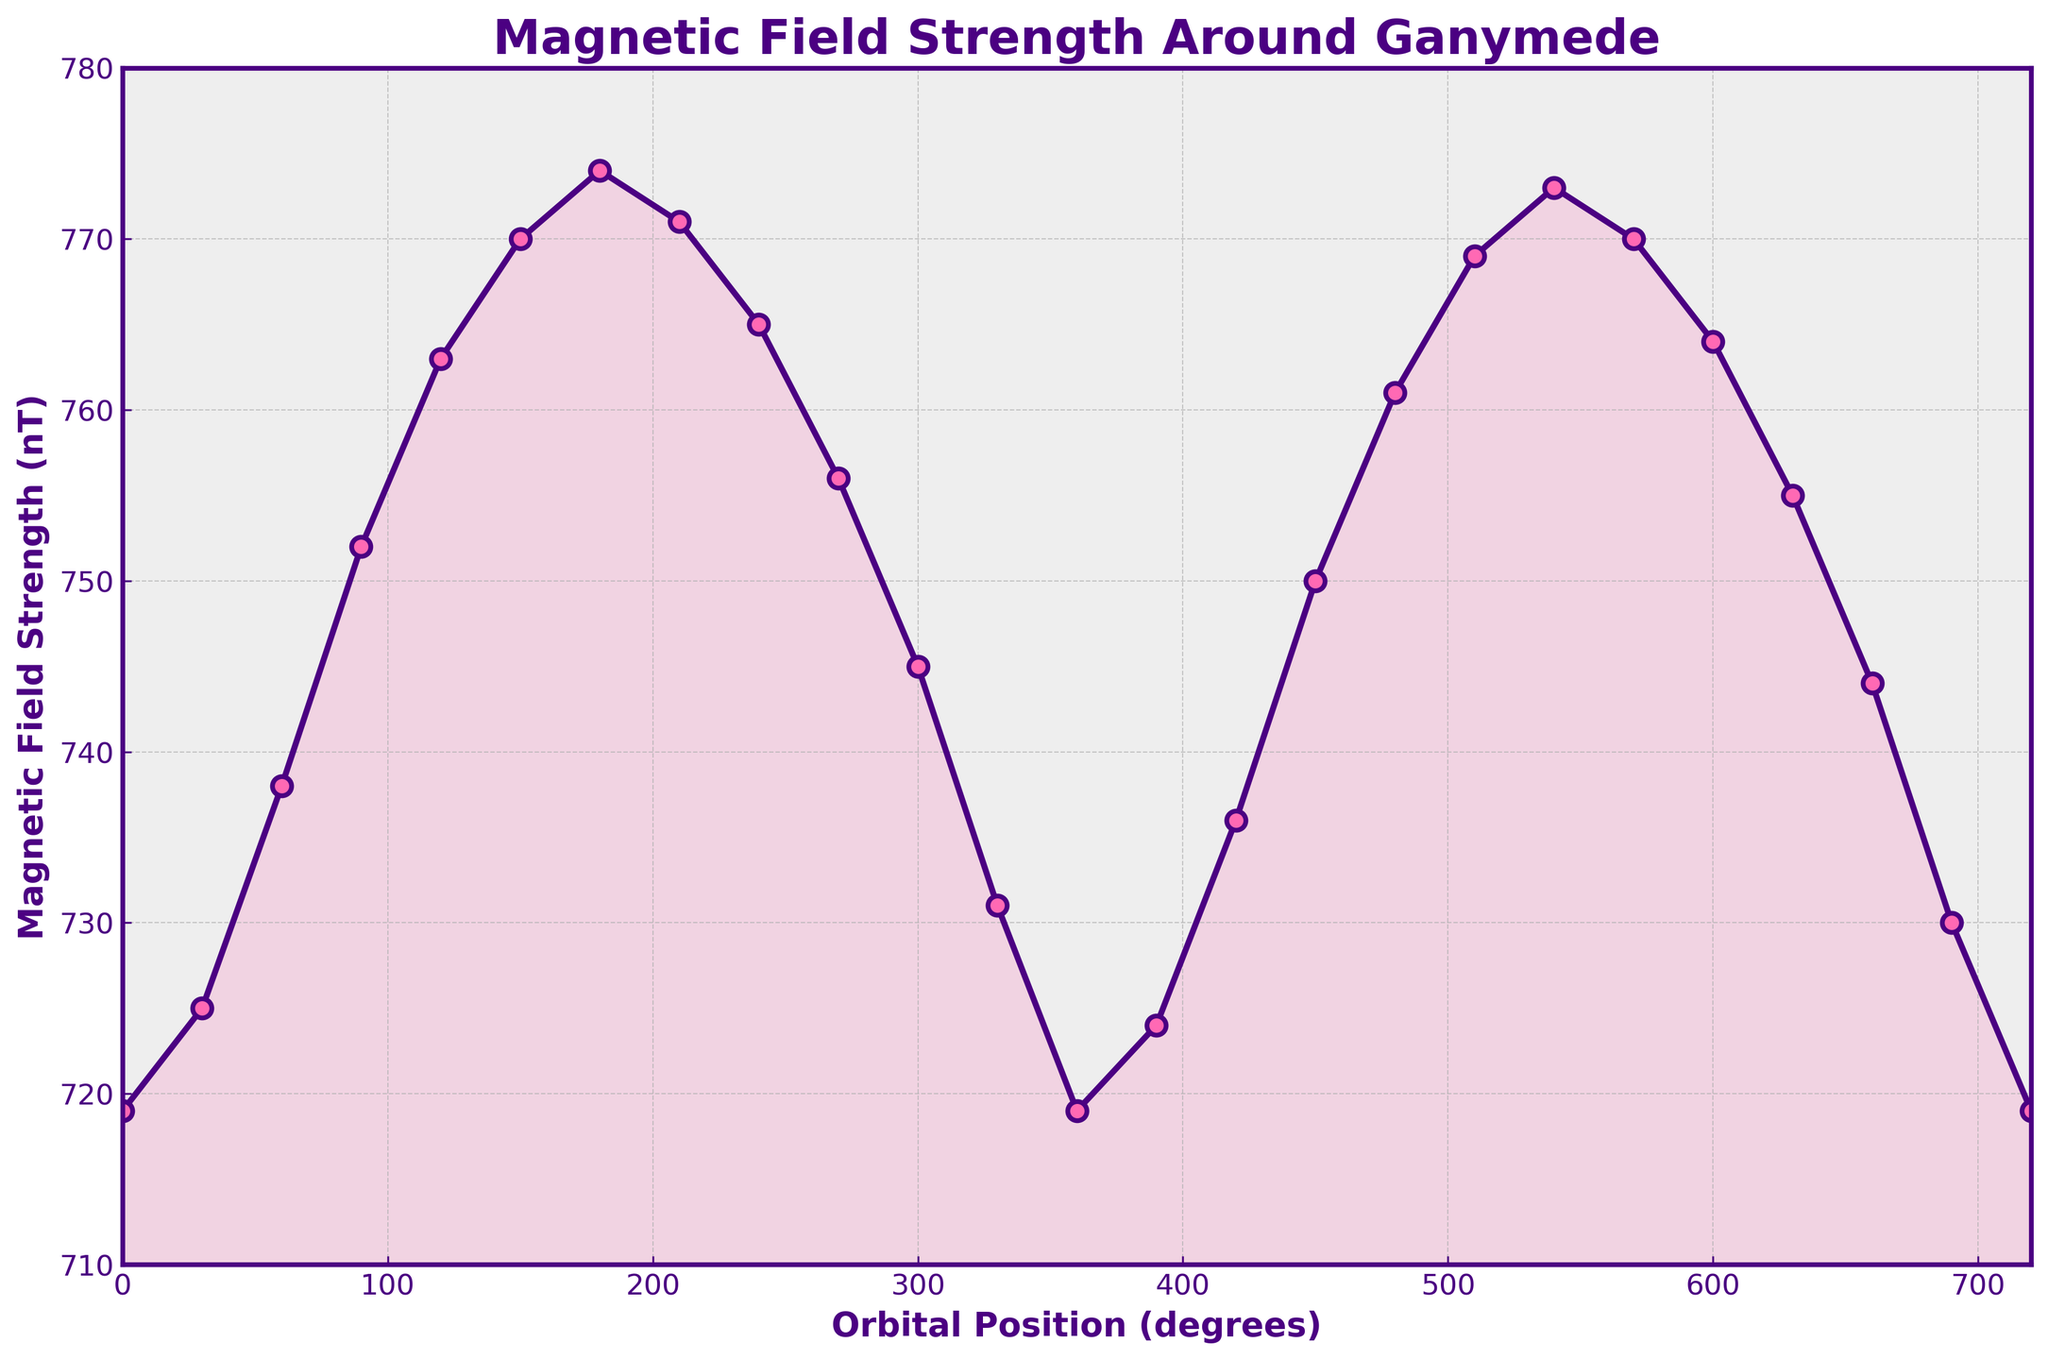How often does the magnetic field strength return to its initial value throughout the plotted orbital positions? The figure shows the magnetic field strength starting and ending at roughly 719 nT, which happens at orbital positions 0, 360, and 720 degrees, indicating it occurs approximately every 360 degrees.
Answer: Every 360 degrees What is the maximum magnetic field strength recorded, and at what orbital position does it occur? The highest point on the graph represents the peak value. According to the figure, the maximum magnetic field strength is 774 nT, which occurs at an orbital position of 180 degrees.
Answer: 774 nT at 180 degrees At which orbital positions is the magnetic field strength exactly 770 nT? By inspecting the graph, the value of 770 nT occurs at approximately 150 and 570 degrees, where the y-values hit the 770 nT mark.
Answer: 150 degrees and 570 degrees How much variation is observed in the magnetic field strength between the lowest and highest recorded values? The lowest value in the graph is approximately 719 nT, and the highest is approximately 774 nT. The variation can be calculated as 774 nT - 719 nT = 55 nT.
Answer: 55 nT What is the average magnetic field strength over one complete orbit (0 to 360 degrees)? To find the average, sum the magnetic field strengths at each orbital position within 0 to 360 degrees and then divide by the number of data points (13 points). (719 + 725 + 738 + 752 + 763 + 770 + 774 + 771 + 765 + 756 + 745 + 731 + 719) / 13 ≈ 749.
Answer: 749 nT Is the magnetic field strength generally increasing, decreasing, or stable over the interval from 0 to 180 degrees? From 0 to 180 degrees, the graph shows an upward trend in the magnetic field strength, gradually increasing from 719 nT to 774 nT.
Answer: Increasing At which orbital positions does the magnetic field strength intersect the 750 nT line? The magnetic field strength intersects the 750 nT line at roughly 90 degrees and again at approximately 450 degrees.
Answer: 90 degrees and 450 degrees What is the range of magnetic field strengths observed in the second half of the orbit (360 to 720 degrees)? From the graph, the values in the second half (360 to 720 degrees) range from approximately 730 nT to 773 nT.
Answer: 730 nT to 773 nT 